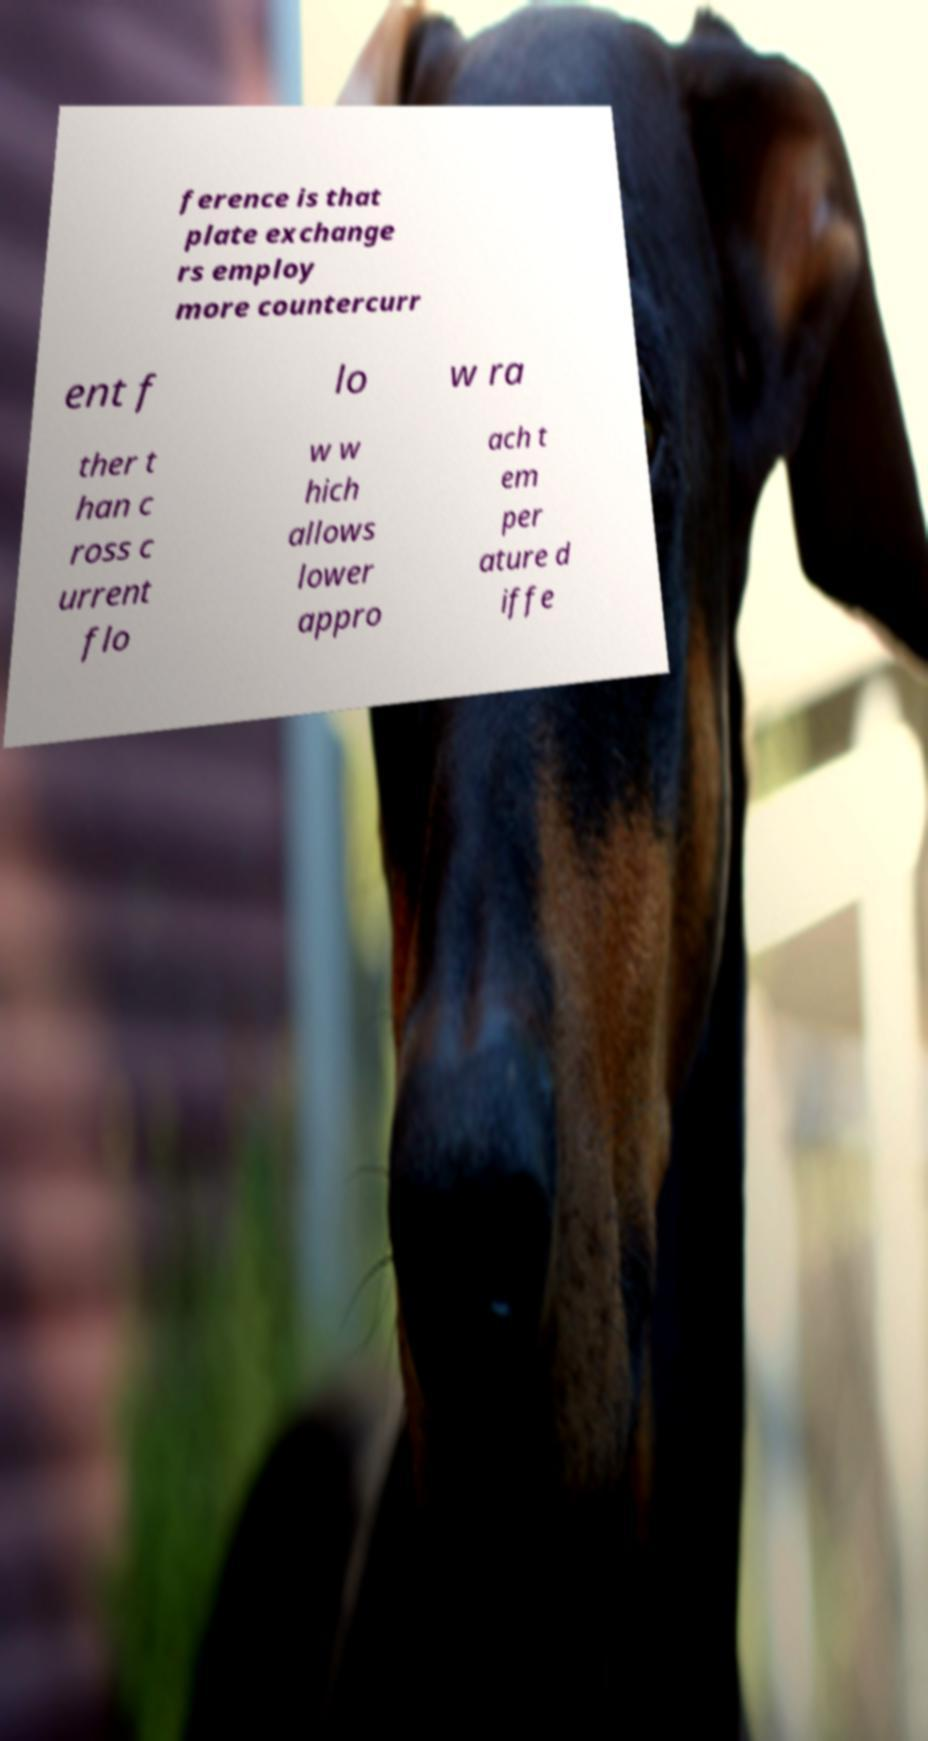I need the written content from this picture converted into text. Can you do that? ference is that plate exchange rs employ more countercurr ent f lo w ra ther t han c ross c urrent flo w w hich allows lower appro ach t em per ature d iffe 